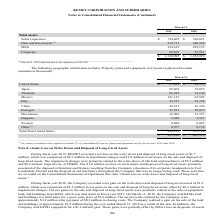From Kemet Corporation's financial document, Which years does the table provide information for Property, plant and equipment, net, based on physical location? The document shows two values: 2019 and 2018. From the document: "2019 2018 2019 2018..." Also, What was the net amount of property, plant and equipment in Japan in 2019? According to the financial document, 89,602 (in thousands). The relevant text states: "Japan 89,602 79,855..." Also, What was the net amount of property, plant and equipment in Thailand in 2018? According to the financial document, 74,100 (in thousands). The relevant text states: "Thailand 82,389 74,100..." Also, How many years did Total net property, plant and equipment from Non-United States regions exceed $400,000 thousand? Based on the analysis, there are 1 instances. The counting process: 2019. Also, can you calculate: What was the change in the net property, plant and equipment in China between 2018 and 2019? Based on the calculation: 45,815-36,396, the result is 9419 (in thousands). This is based on the information: "China 45,815 36,396 China 45,815 36,396..." The key data points involved are: 36,396, 45,815. Also, can you calculate: What was the percentage change in the total net property, plant and equipment between 2018 and 2019? To answer this question, I need to perform calculations using the financial data. The calculation is: (495,280-405,316)/405,316, which equals 22.2 (percentage). This is based on the information: "$ 495,280 $ 405,316 $ 495,280 $ 405,316..." The key data points involved are: 405,316, 495,280. 